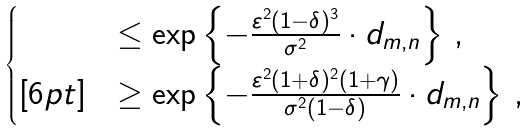Convert formula to latex. <formula><loc_0><loc_0><loc_500><loc_500>\begin{cases} & \leq \exp \left \{ - \frac { \varepsilon ^ { 2 } ( 1 - \delta ) ^ { 3 } } { \sigma ^ { 2 } } \cdot d _ { m , n } \right \} \, , \\ [ 6 p t ] & \geq \exp \left \{ - \frac { \varepsilon ^ { 2 } ( 1 + \delta ) ^ { 2 } ( 1 + \gamma ) } { \sigma ^ { 2 } ( 1 - \delta ) } \cdot d _ { m , n } \right \} \, , \end{cases}</formula> 